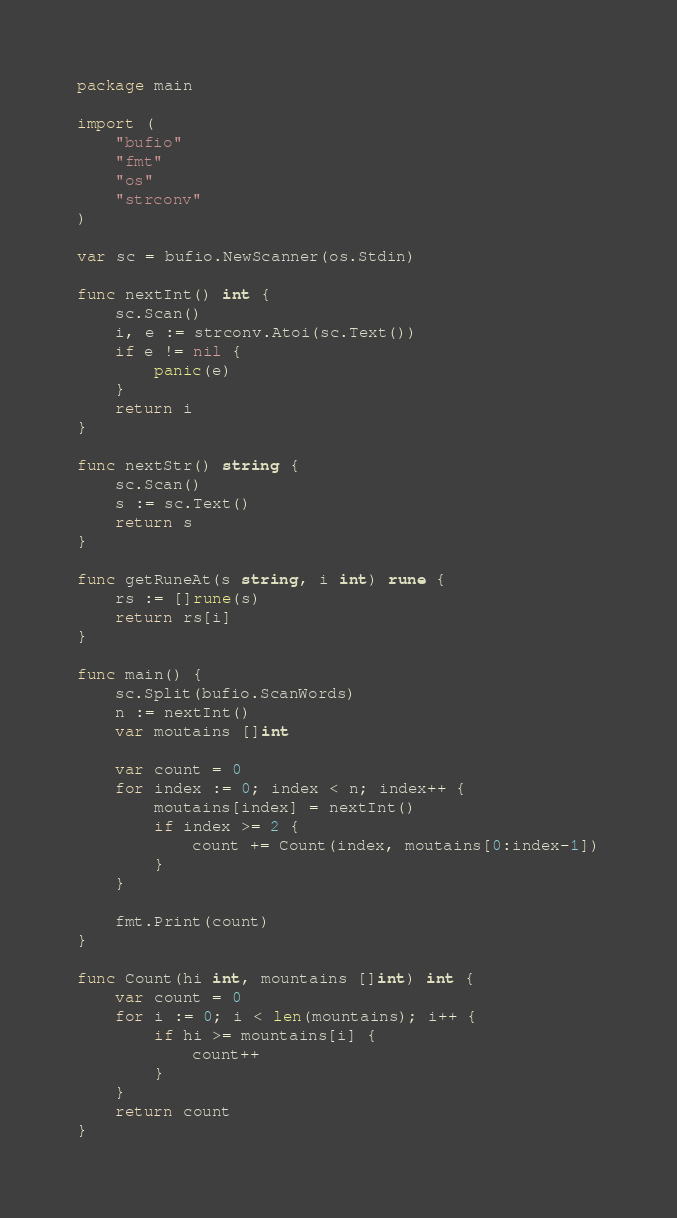Convert code to text. <code><loc_0><loc_0><loc_500><loc_500><_Go_>package main

import (
	"bufio"
	"fmt"
	"os"
	"strconv"
)

var sc = bufio.NewScanner(os.Stdin)

func nextInt() int {
	sc.Scan()
	i, e := strconv.Atoi(sc.Text())
	if e != nil {
		panic(e)
	}
	return i
}

func nextStr() string {
	sc.Scan()
	s := sc.Text()
	return s
}

func getRuneAt(s string, i int) rune {
	rs := []rune(s)
	return rs[i]
}

func main() {
	sc.Split(bufio.ScanWords)
	n := nextInt()
	var moutains []int

	var count = 0
	for index := 0; index < n; index++ {
		moutains[index] = nextInt()
		if index >= 2 {
			count += Count(index, moutains[0:index-1])
		}
	}

	fmt.Print(count)
}

func Count(hi int, mountains []int) int {
	var count = 0
	for i := 0; i < len(mountains); i++ {
		if hi >= mountains[i] {
			count++
		}
	}
	return count
}
</code> 